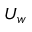Convert formula to latex. <formula><loc_0><loc_0><loc_500><loc_500>U _ { w }</formula> 